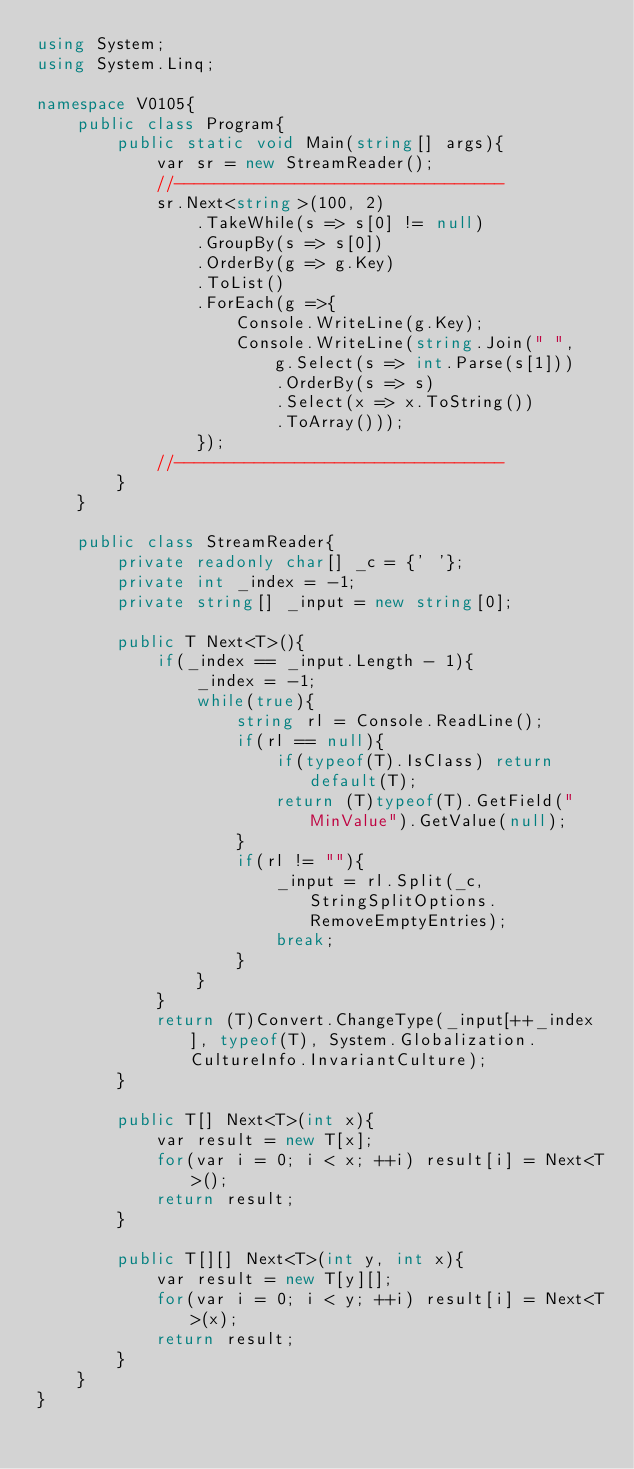Convert code to text. <code><loc_0><loc_0><loc_500><loc_500><_C#_>using System;
using System.Linq;

namespace V0105{
    public class Program{
        public static void Main(string[] args){
            var sr = new StreamReader();
            //---------------------------------
            sr.Next<string>(100, 2)
                .TakeWhile(s => s[0] != null)
                .GroupBy(s => s[0])
                .OrderBy(g => g.Key)
                .ToList()
                .ForEach(g =>{
                    Console.WriteLine(g.Key);
                    Console.WriteLine(string.Join(" ",
                        g.Select(s => int.Parse(s[1]))
                        .OrderBy(s => s)
                        .Select(x => x.ToString())
                        .ToArray()));
                });
            //---------------------------------
        }
    }

    public class StreamReader{
        private readonly char[] _c = {' '};
        private int _index = -1;
        private string[] _input = new string[0];

        public T Next<T>(){
            if(_index == _input.Length - 1){
                _index = -1;
                while(true){
                    string rl = Console.ReadLine();
                    if(rl == null){
                        if(typeof(T).IsClass) return default(T);
                        return (T)typeof(T).GetField("MinValue").GetValue(null);
                    }
                    if(rl != ""){
                        _input = rl.Split(_c, StringSplitOptions.RemoveEmptyEntries);
                        break;
                    }
                }
            }
            return (T)Convert.ChangeType(_input[++_index], typeof(T), System.Globalization.CultureInfo.InvariantCulture);
        }

        public T[] Next<T>(int x){
            var result = new T[x];
            for(var i = 0; i < x; ++i) result[i] = Next<T>();
            return result;
        }

        public T[][] Next<T>(int y, int x){
            var result = new T[y][];
            for(var i = 0; i < y; ++i) result[i] = Next<T>(x);
            return result;
        }
    }
}</code> 